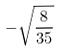Convert formula to latex. <formula><loc_0><loc_0><loc_500><loc_500>- \sqrt { \frac { 8 } { 3 5 } }</formula> 